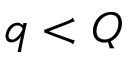Convert formula to latex. <formula><loc_0><loc_0><loc_500><loc_500>q < Q</formula> 